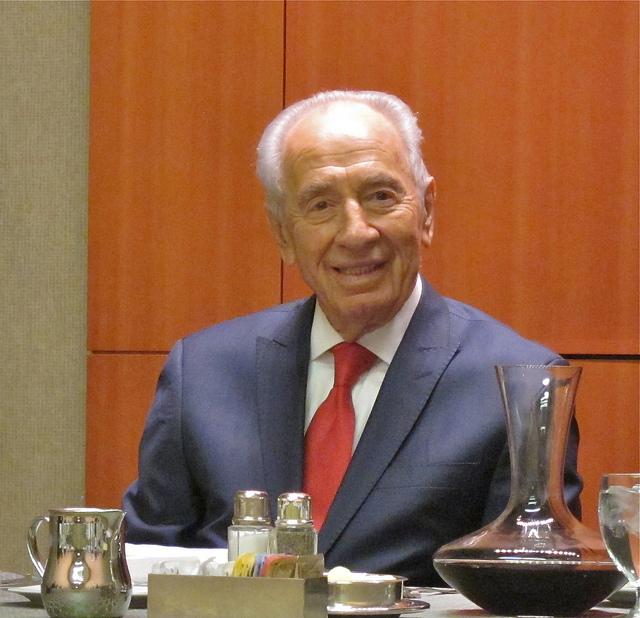What is the man wearing?
Keep it brief. Suit and tie. Do you think he is cooking?
Short answer required. No. What color tie is the man wearing?
Concise answer only. Red. 